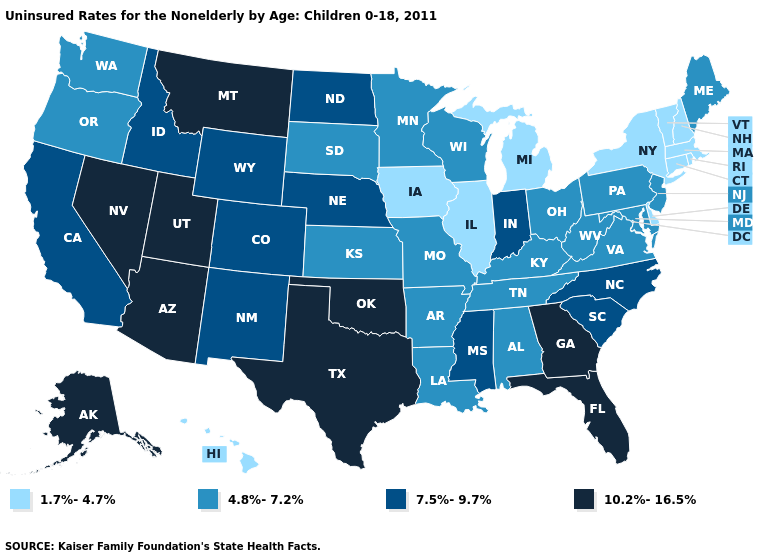What is the value of Maryland?
Keep it brief. 4.8%-7.2%. Name the states that have a value in the range 10.2%-16.5%?
Give a very brief answer. Alaska, Arizona, Florida, Georgia, Montana, Nevada, Oklahoma, Texas, Utah. Among the states that border Maine , which have the highest value?
Keep it brief. New Hampshire. What is the highest value in the USA?
Write a very short answer. 10.2%-16.5%. Name the states that have a value in the range 1.7%-4.7%?
Quick response, please. Connecticut, Delaware, Hawaii, Illinois, Iowa, Massachusetts, Michigan, New Hampshire, New York, Rhode Island, Vermont. Name the states that have a value in the range 7.5%-9.7%?
Short answer required. California, Colorado, Idaho, Indiana, Mississippi, Nebraska, New Mexico, North Carolina, North Dakota, South Carolina, Wyoming. Does Iowa have a lower value than Hawaii?
Keep it brief. No. Does Georgia have the lowest value in the USA?
Quick response, please. No. What is the value of Virginia?
Short answer required. 4.8%-7.2%. What is the value of Mississippi?
Write a very short answer. 7.5%-9.7%. What is the highest value in states that border New Hampshire?
Quick response, please. 4.8%-7.2%. What is the value of Connecticut?
Give a very brief answer. 1.7%-4.7%. What is the highest value in states that border Illinois?
Be succinct. 7.5%-9.7%. What is the value of Washington?
Quick response, please. 4.8%-7.2%. Name the states that have a value in the range 7.5%-9.7%?
Be succinct. California, Colorado, Idaho, Indiana, Mississippi, Nebraska, New Mexico, North Carolina, North Dakota, South Carolina, Wyoming. 